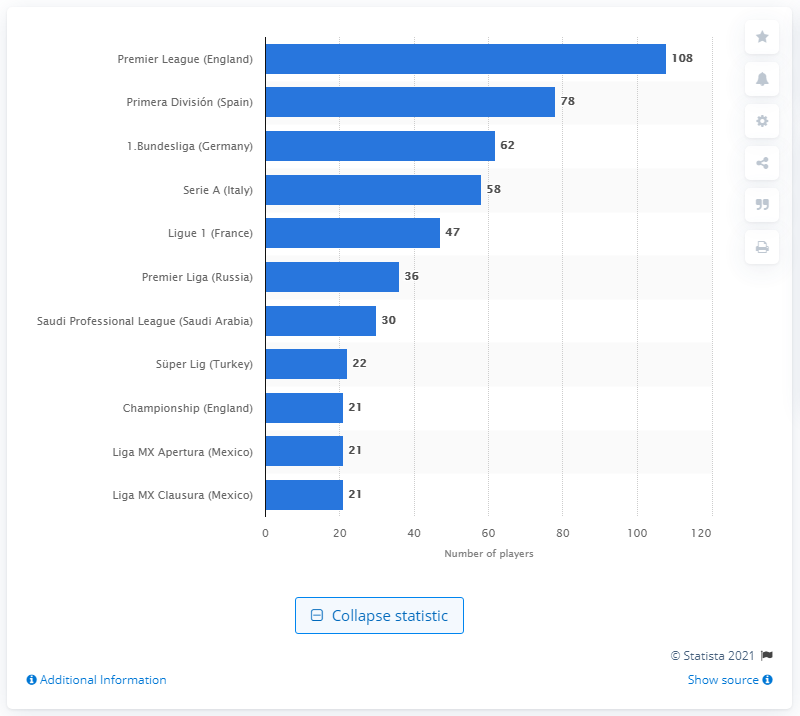List a handful of essential elements in this visual. There were 108 players who participated in the Premier League in 2018. 